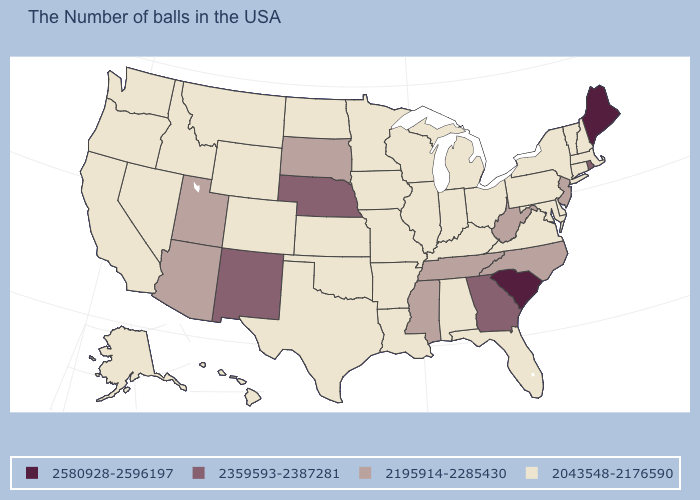What is the highest value in the Northeast ?
Be succinct. 2580928-2596197. What is the value of Oregon?
Quick response, please. 2043548-2176590. Among the states that border Delaware , which have the lowest value?
Keep it brief. Maryland, Pennsylvania. What is the value of Colorado?
Be succinct. 2043548-2176590. What is the value of Hawaii?
Keep it brief. 2043548-2176590. Name the states that have a value in the range 2580928-2596197?
Keep it brief. Maine, South Carolina. Which states have the lowest value in the West?
Give a very brief answer. Wyoming, Colorado, Montana, Idaho, Nevada, California, Washington, Oregon, Alaska, Hawaii. Name the states that have a value in the range 2359593-2387281?
Quick response, please. Rhode Island, Georgia, Nebraska, New Mexico. Name the states that have a value in the range 2043548-2176590?
Be succinct. Massachusetts, New Hampshire, Vermont, Connecticut, New York, Delaware, Maryland, Pennsylvania, Virginia, Ohio, Florida, Michigan, Kentucky, Indiana, Alabama, Wisconsin, Illinois, Louisiana, Missouri, Arkansas, Minnesota, Iowa, Kansas, Oklahoma, Texas, North Dakota, Wyoming, Colorado, Montana, Idaho, Nevada, California, Washington, Oregon, Alaska, Hawaii. What is the value of Texas?
Give a very brief answer. 2043548-2176590. Is the legend a continuous bar?
Quick response, please. No. Does Texas have the lowest value in the South?
Concise answer only. Yes. Name the states that have a value in the range 2195914-2285430?
Keep it brief. New Jersey, North Carolina, West Virginia, Tennessee, Mississippi, South Dakota, Utah, Arizona. Among the states that border Idaho , which have the lowest value?
Concise answer only. Wyoming, Montana, Nevada, Washington, Oregon. Name the states that have a value in the range 2043548-2176590?
Quick response, please. Massachusetts, New Hampshire, Vermont, Connecticut, New York, Delaware, Maryland, Pennsylvania, Virginia, Ohio, Florida, Michigan, Kentucky, Indiana, Alabama, Wisconsin, Illinois, Louisiana, Missouri, Arkansas, Minnesota, Iowa, Kansas, Oklahoma, Texas, North Dakota, Wyoming, Colorado, Montana, Idaho, Nevada, California, Washington, Oregon, Alaska, Hawaii. 